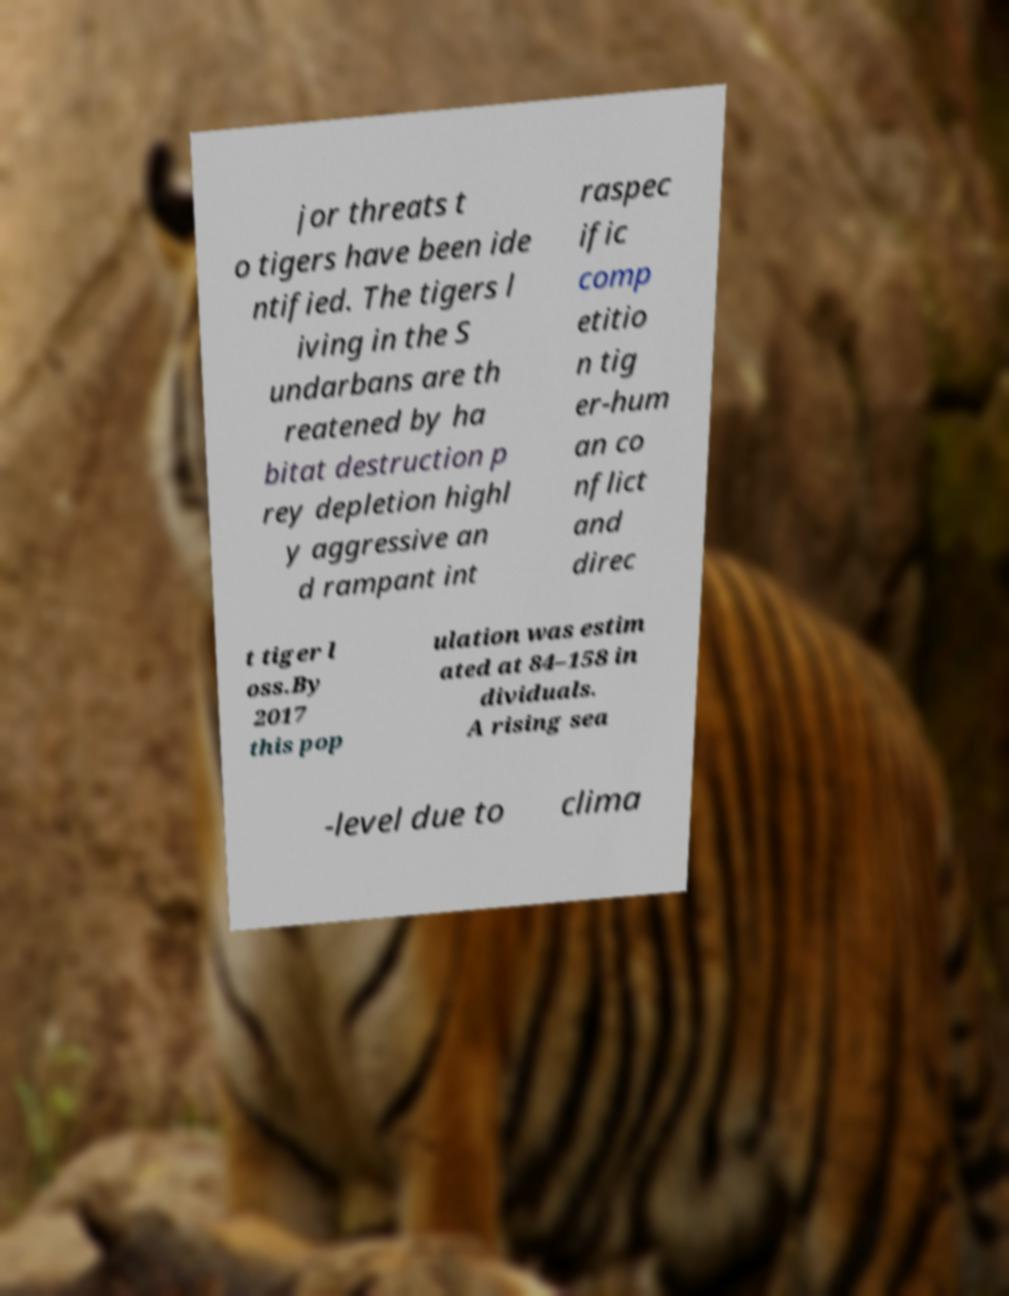Could you extract and type out the text from this image? jor threats t o tigers have been ide ntified. The tigers l iving in the S undarbans are th reatened by ha bitat destruction p rey depletion highl y aggressive an d rampant int raspec ific comp etitio n tig er-hum an co nflict and direc t tiger l oss.By 2017 this pop ulation was estim ated at 84–158 in dividuals. A rising sea -level due to clima 